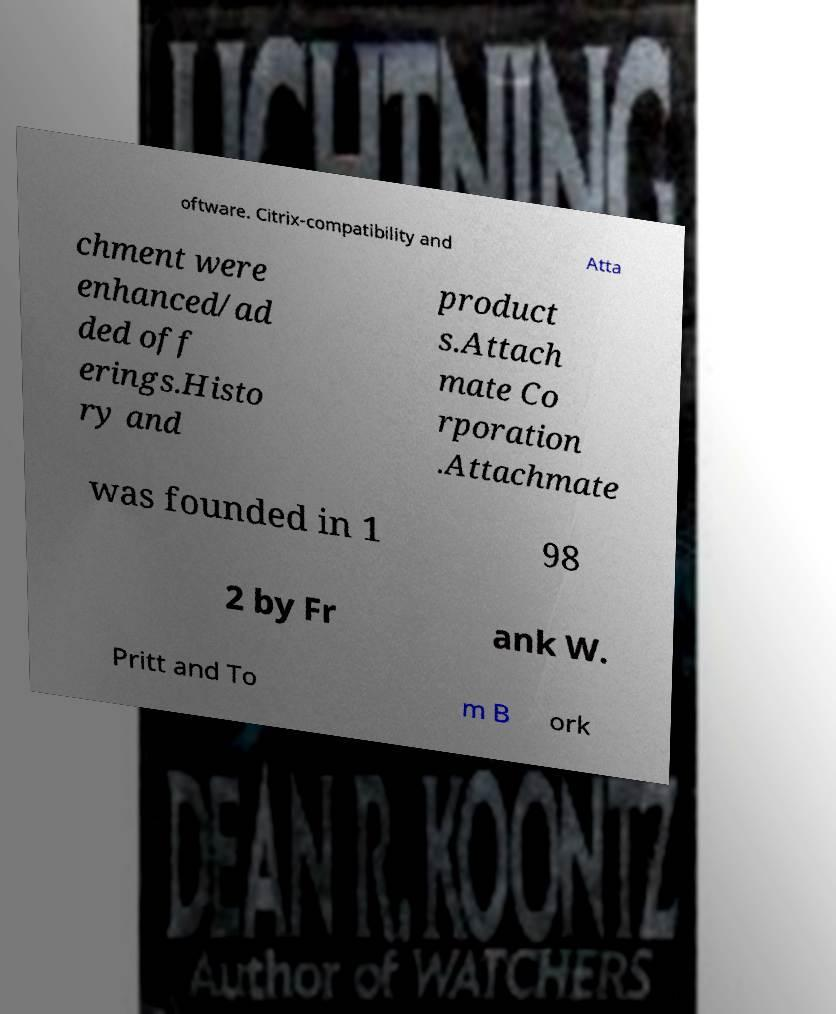For documentation purposes, I need the text within this image transcribed. Could you provide that? oftware. Citrix-compatibility and Atta chment were enhanced/ad ded off erings.Histo ry and product s.Attach mate Co rporation .Attachmate was founded in 1 98 2 by Fr ank W. Pritt and To m B ork 